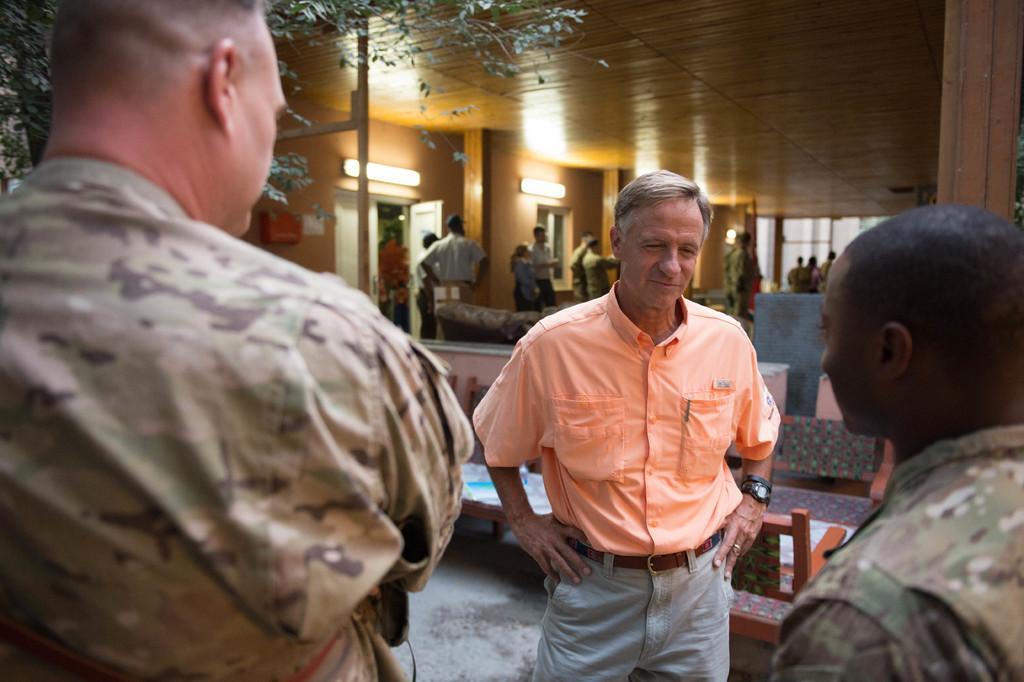Describe this image in one or two sentences. This picture shows few people standing and we see chairs and a tree and a couple of lights and we see man wore orange color shirt and a black wrist watch to his hand. 